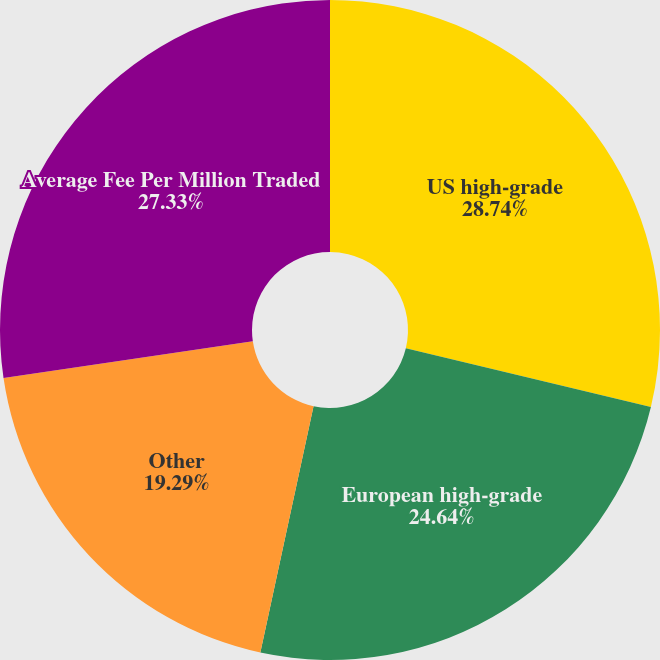Convert chart to OTSL. <chart><loc_0><loc_0><loc_500><loc_500><pie_chart><fcel>US high-grade<fcel>European high-grade<fcel>Other<fcel>Average Fee Per Million Traded<nl><fcel>28.75%<fcel>24.64%<fcel>19.29%<fcel>27.33%<nl></chart> 